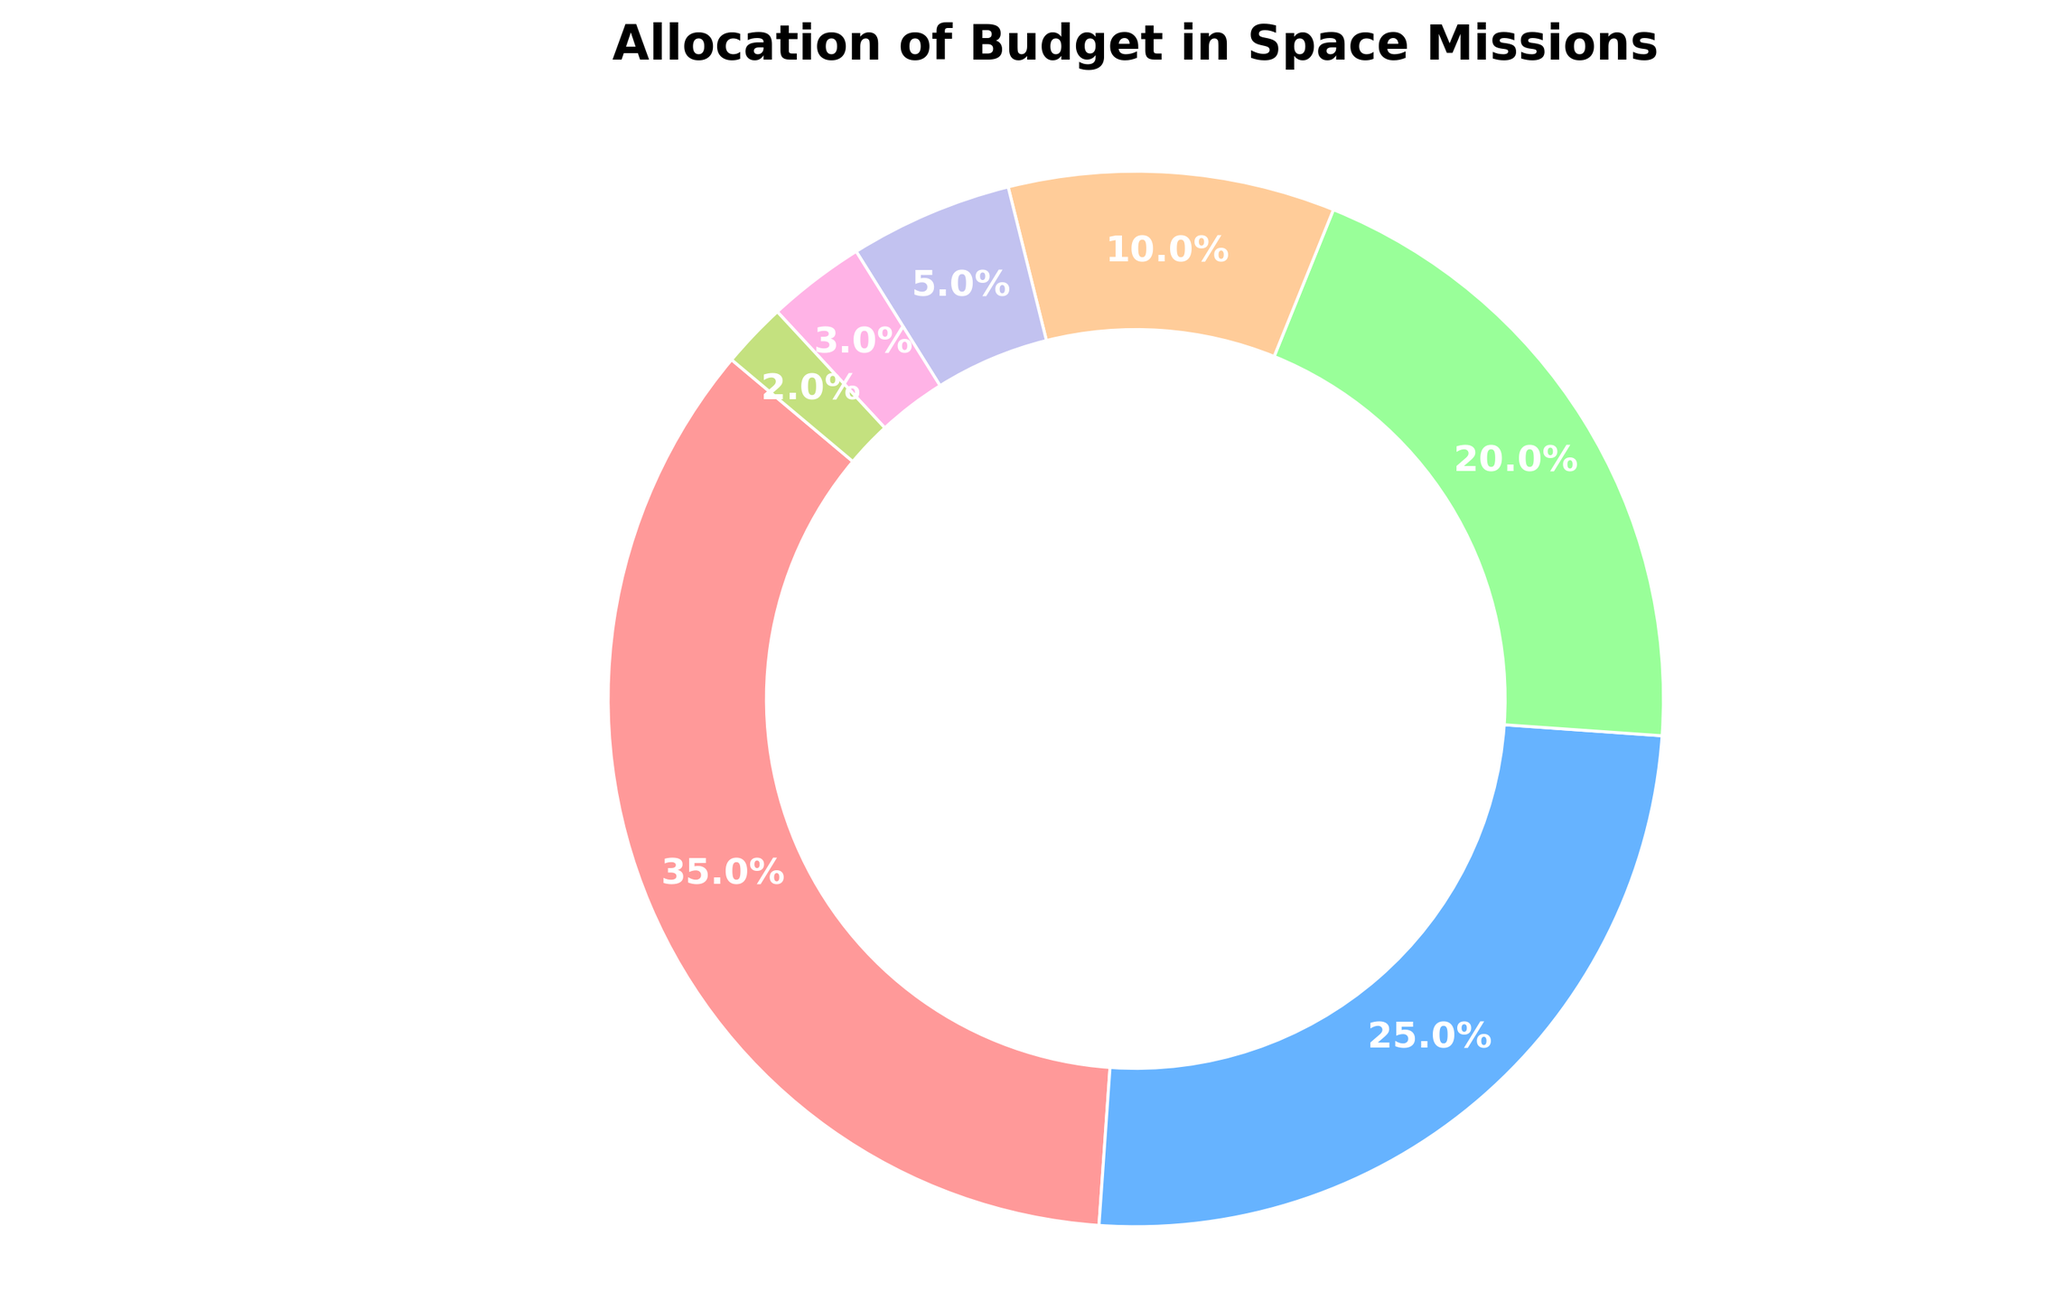What percentage of the budget is allocated to Research and Development? The figure shows the percentage allocated to each category. From the data visible in the pie chart, Research and Development is shown as having a 35% allocation.
Answer: 35% Which category receives the smallest percentage of the budget? By examining the smallest slice of the pie chart, it is evident that the smallest percentage is allocated to Contingency Reserves. The chart label for Contingency Reserves shows 2%.
Answer: Contingency Reserves What is the combined percentage allocated to Spacecraft Construction and Mission Operations? To find this, you sum the percentages of Spacecraft Construction and Mission Operations. The chart lists these as 25% and 20%, respectively. Therefore, 25% + 20% = 45%.
Answer: 45% Which categories together account for more than half of the budget? First, identify the categories and their percentages: Research and Development (35%), Spacecraft Construction (25%), Mission Operations (20%), Launch Services (10%), Ground Support (5%), Public Outreach (3%), Contingency Reserves (2%). Then, sum the percentages to see which combinations exceed 50%. Research and Development (35%) + Spacecraft Construction (25%) = 60%, which is more than half. Any combination including Research and Development (35%) plus another category like Mission Operations (20%) also exceeds 50%.
Answer: Research and Development and Spacecraft Construction How does the percentage of Launch Services compare to that of Public Outreach? The percentage of the budget allocated to Launch Services can be compared to Public Outreach by examining their respective slices in the pie chart. The chart shows that Launch Services is allocated 10% while Public Outreach is allocated 3%. Therefore, Launch Services is greater than Public Outreach.
Answer: Launch Services is greater What is the difference between the highest and lowest allocated categories? From the pie chart, the highest allocated category is Research and Development at 35%, and the lowest is Contingency Reserves at 2%. The difference is calculated as 35% - 2% = 33%.
Answer: 33% What amount of the budget is allocated to non-operational categories (excluding Mission Operations and Ground Support)? First, sum the percentages of the non-operational categories: Research and Development (35%), Spacecraft Construction (25%), Launch Services (10%), Public Outreach (3%), Contingency Reserves (2%). Adding these together: 35% + 25% + 10% + 3% + 2% = 75%.
Answer: 75% What two categories combined roughly equal the allocation for Research and Development? By looking at the chart, identify two categories whose combined percentages approximate 35%. Spacecraft Construction (25%) and Mission Operations (20%) together equal 45%, which is close but not exact. Launch Services (10%) and Mission Operations (20%) together equal 30%, which is closer but still not exact. Therefore, Spacecraft Construction and Mission Operations (20%) are the closest combinational total approximately equaling the Research and Development allocation.
Answer: Spacecraft Construction and Mission Operations What proportion of the budget is allocated to categories related to the mission's physical elements (Spacecraft Construction, Launch Services, Ground Support)? Adding the percentages of Spacecraft Construction (25%), Launch Services (10%), and Ground Support (5%) together gives 25% + 10% + 5% = 40%.
Answer: 40% 